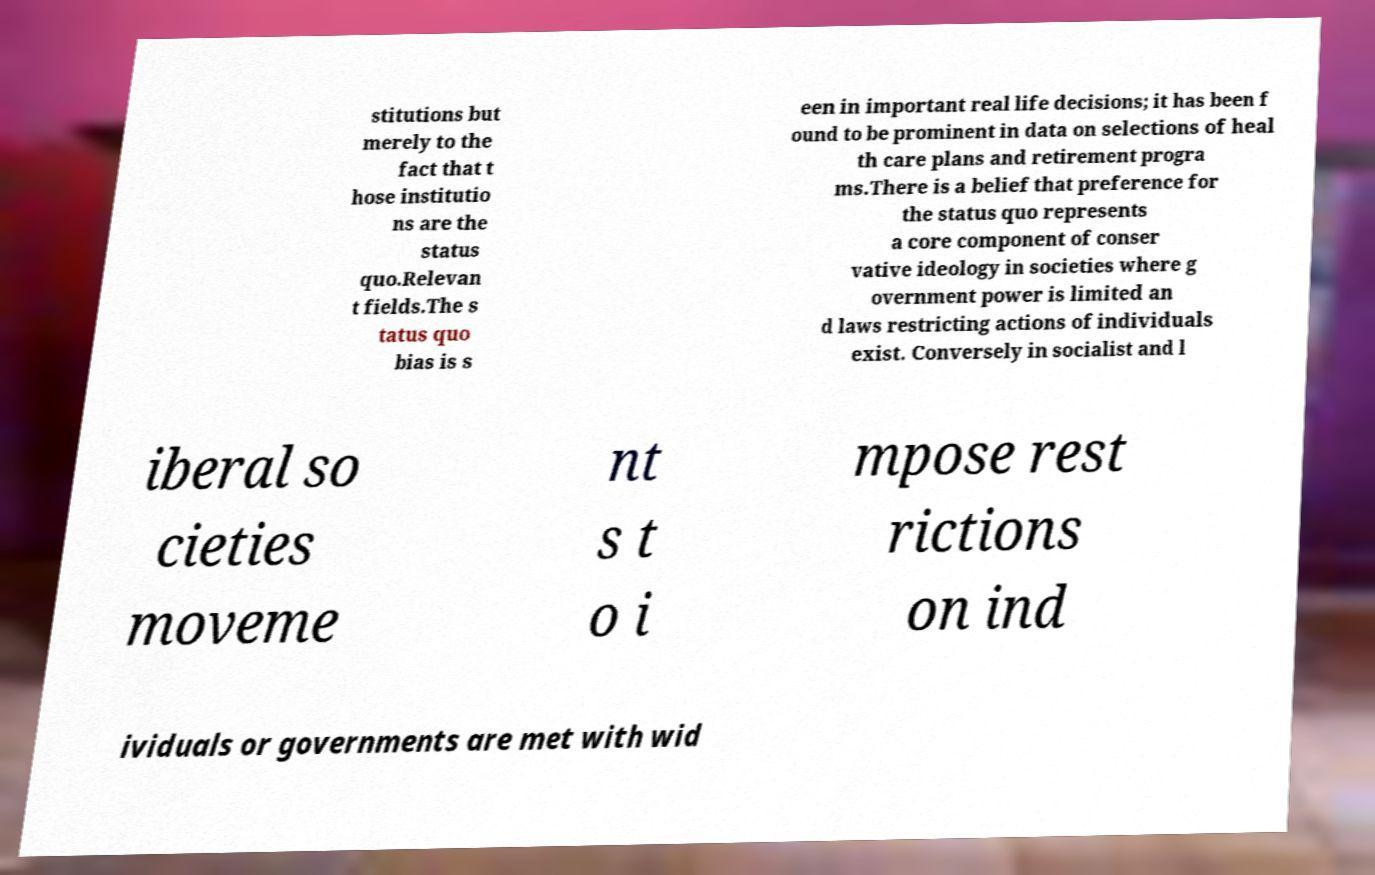Please identify and transcribe the text found in this image. stitutions but merely to the fact that t hose institutio ns are the status quo.Relevan t fields.The s tatus quo bias is s een in important real life decisions; it has been f ound to be prominent in data on selections of heal th care plans and retirement progra ms.There is a belief that preference for the status quo represents a core component of conser vative ideology in societies where g overnment power is limited an d laws restricting actions of individuals exist. Conversely in socialist and l iberal so cieties moveme nt s t o i mpose rest rictions on ind ividuals or governments are met with wid 